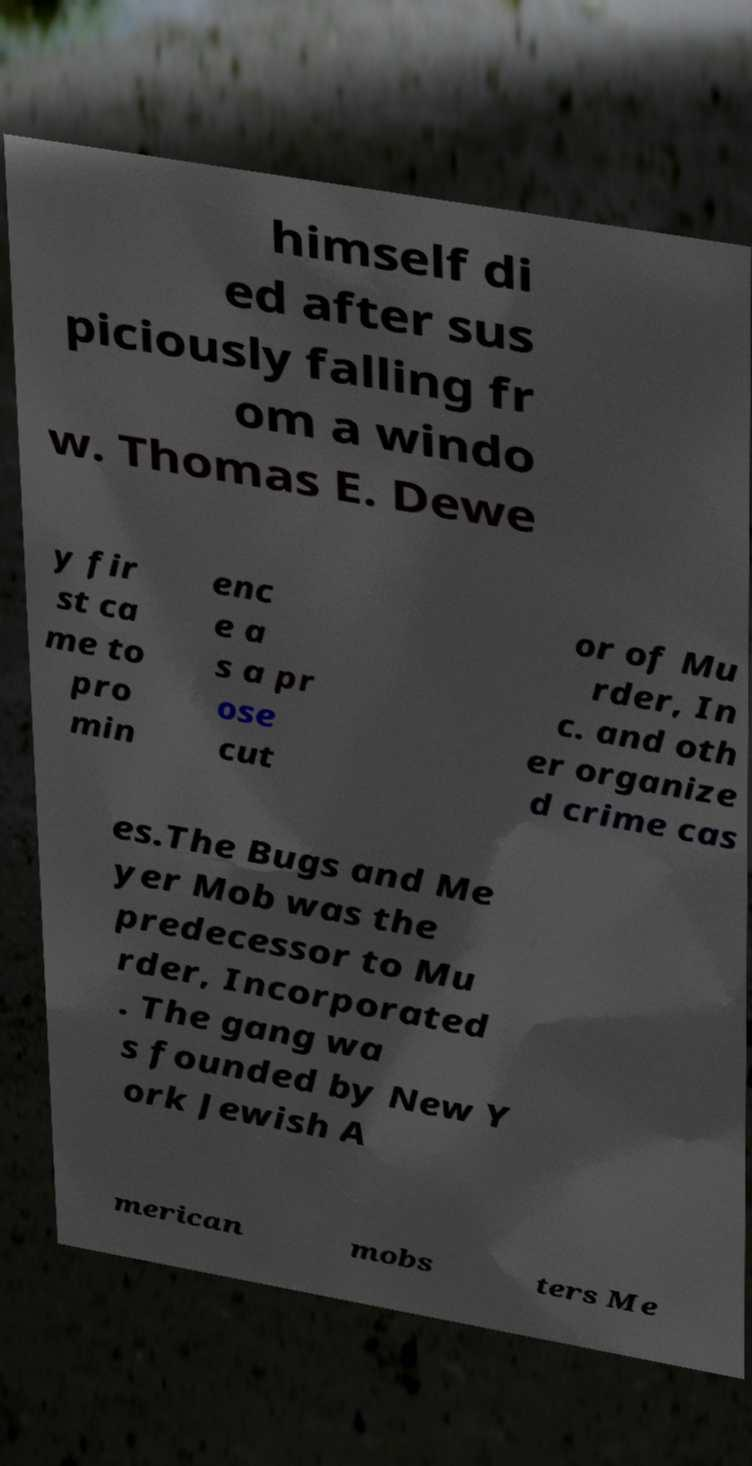Please read and relay the text visible in this image. What does it say? himself di ed after sus piciously falling fr om a windo w. Thomas E. Dewe y fir st ca me to pro min enc e a s a pr ose cut or of Mu rder, In c. and oth er organize d crime cas es.The Bugs and Me yer Mob was the predecessor to Mu rder, Incorporated . The gang wa s founded by New Y ork Jewish A merican mobs ters Me 